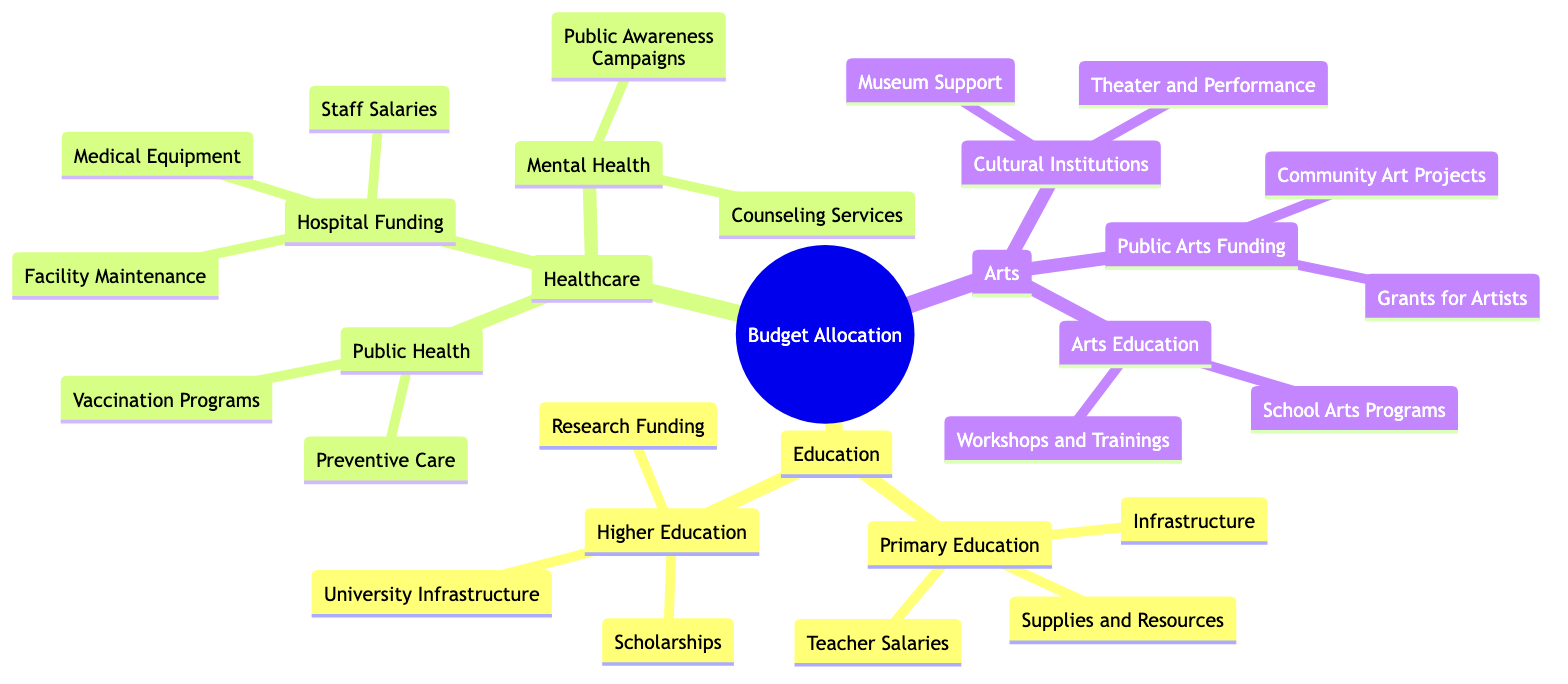What are the three main branches of the budget allocation? The main branches are visually depicted as three primary categories: Education, Healthcare, and Arts.
Answer: Education, Healthcare, Arts How many sub-branches are under Primary Education? Under Primary Education, there are three sub-branches listed: Infrastructure, Teacher Salaries, and Supplies and Resources.
Answer: 3 What category includes Public Awareness Campaigns? Public Awareness Campaigns are a sub-branch under the Mental Health branch, which falls under Healthcare.
Answer: Mental Health Which branch has a sub-branch specifically for Grants for Artists? The Public Arts Funding sub-branch falls under the Arts branch and specifically includes Grants for Artists as one of its components.
Answer: Arts What common theme is shared between Preventive Care and Vaccination Programs? Both sub-branches are categorized under Public Health, indicating a focus on preventive measures in healthcare.
Answer: Public Health Which area includes both University Infrastructure and Research Funding? These two sub-branches are part of the Higher Education branch, focusing on supporting and enhancing universities.
Answer: Higher Education How many branches fall under Healthcare? The Healthcare branch breaks down into three main sub-branches: Public Health, Hospital Funding, and Mental Health, totaling three.
Answer: 3 What type of projects are included under Community Art Projects? Community Art Projects, along with Grants for Artists, are under the Public Arts Funding sub-branch, focusing on community engagement in the arts.
Answer: Community Art Projects Which branch includes Counseling Services? Counseling Services are part of the Mental Health sub-branch, located under the Healthcare branch.
Answer: Healthcare 